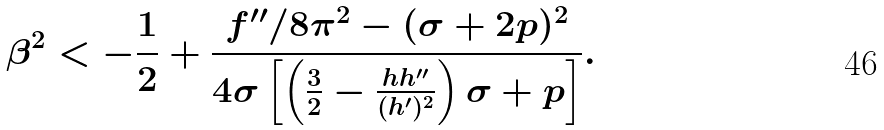Convert formula to latex. <formula><loc_0><loc_0><loc_500><loc_500>\beta ^ { 2 } < - \frac { 1 } { 2 } + \frac { f ^ { \prime \prime } / 8 \pi ^ { 2 } - ( \sigma + 2 p ) ^ { 2 } } { 4 \sigma \left [ \left ( \frac { 3 } { 2 } - \frac { h h ^ { \prime \prime } } { ( h ^ { \prime } ) ^ { 2 } } \right ) \sigma + p \right ] } .</formula> 